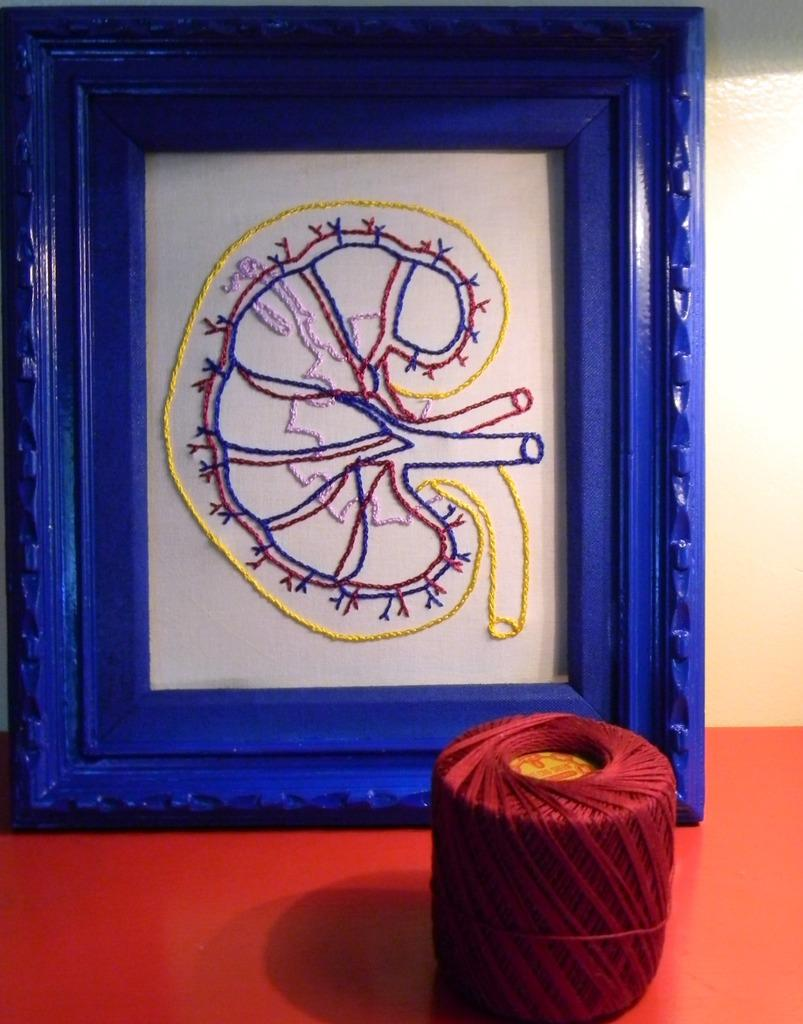What is located in the foreground of the picture? There is a frame and thread in the foreground of the picture. Where are the frame and thread placed? Both the frame and thread are placed on a table. What type of bread can be seen in the picture? There is no bread present in the picture; it features a frame and thread placed on a table. 